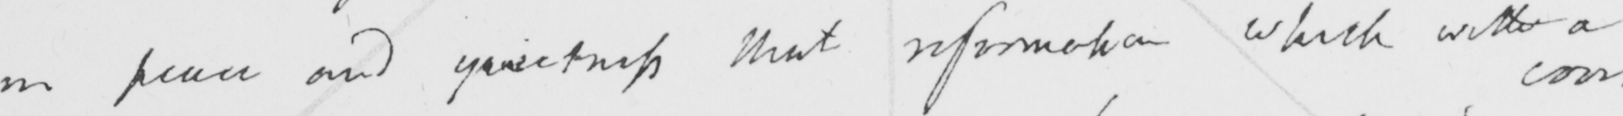What is written in this line of handwriting? in peace and quietness that reformation which with a 